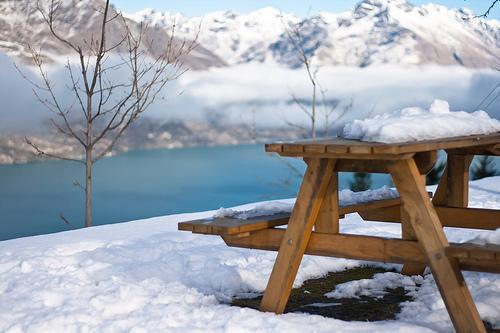How many benchs?
Give a very brief answer. 1. 